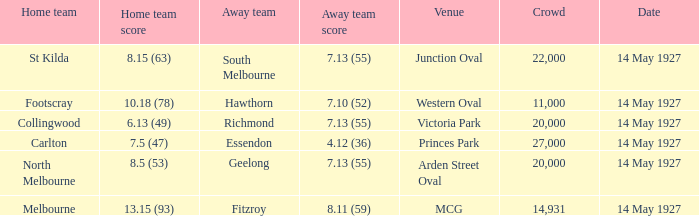On what date does Essendon play as the away team? 14 May 1927. 